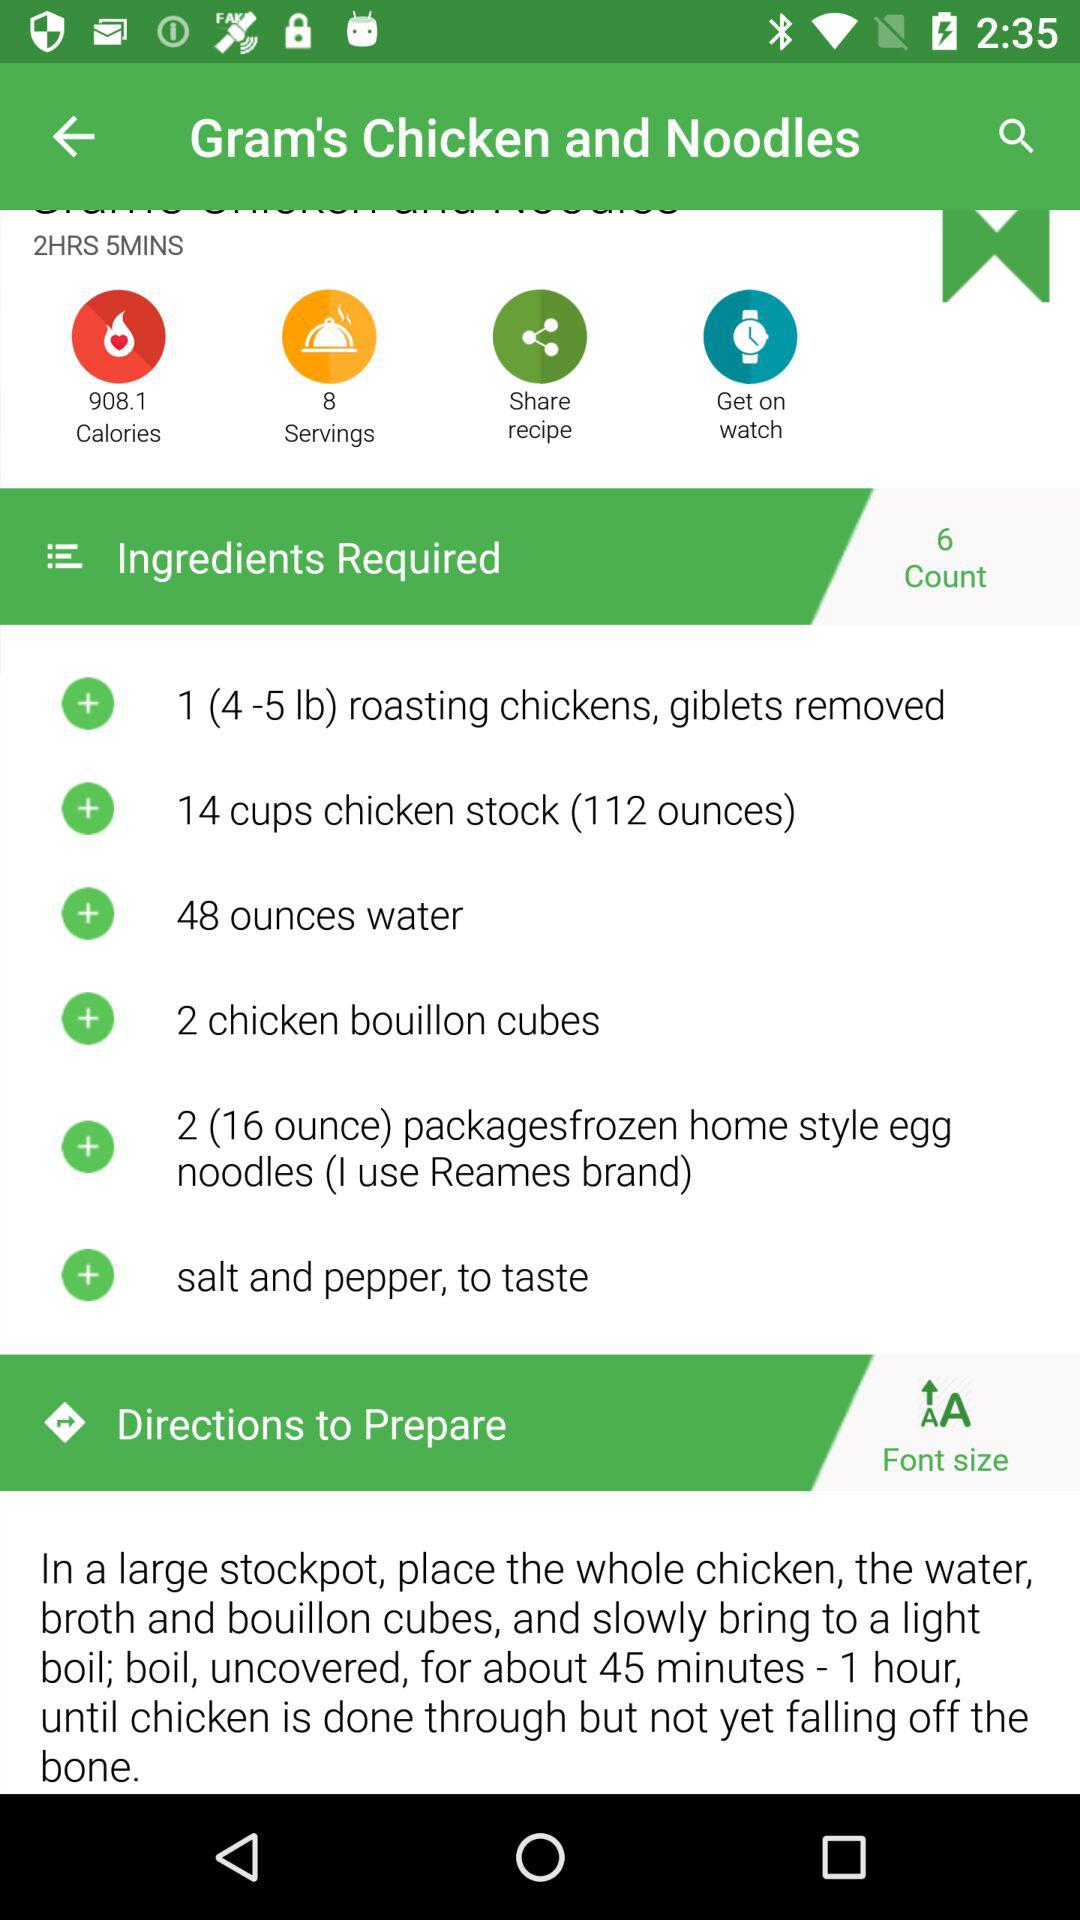How many minutes does it take to cook the chicken?
Answer the question using a single word or phrase. 45 minutes - 1 hour 